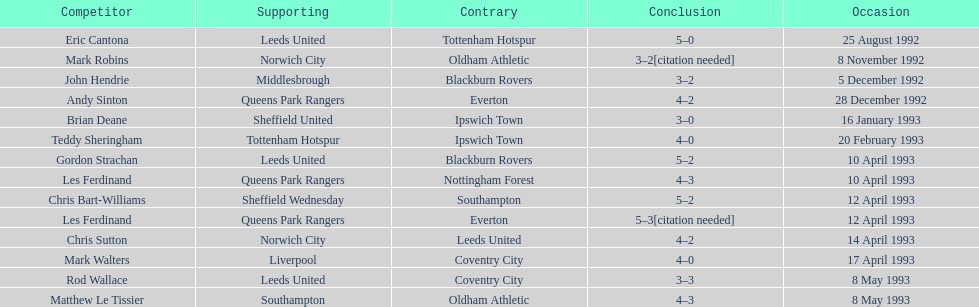Name the only player from france. Eric Cantona. 